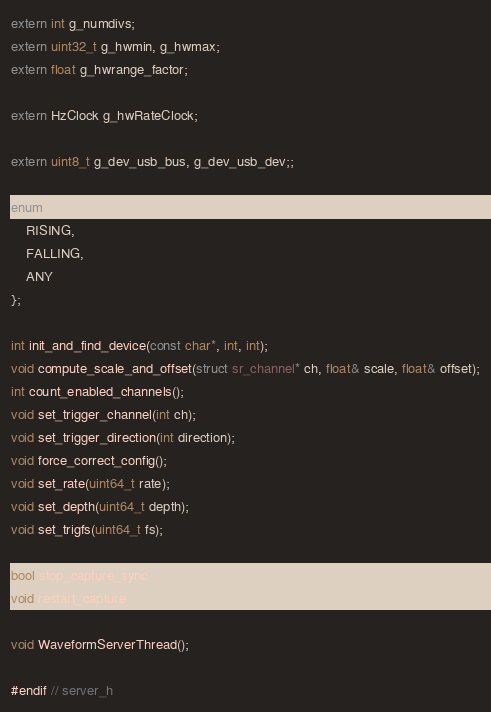<code> <loc_0><loc_0><loc_500><loc_500><_C_>extern int g_numdivs;
extern uint32_t g_hwmin, g_hwmax;
extern float g_hwrange_factor;

extern HzClock g_hwRateClock;

extern uint8_t g_dev_usb_bus, g_dev_usb_dev;;

enum trigger_direction {
	RISING,
	FALLING,
	ANY
};

int init_and_find_device(const char*, int, int);
void compute_scale_and_offset(struct sr_channel* ch, float& scale, float& offset);
int count_enabled_channels();
void set_trigger_channel(int ch);
void set_trigger_direction(int direction);
void force_correct_config();
void set_rate(uint64_t rate);
void set_depth(uint64_t depth);
void set_trigfs(uint64_t fs);

bool stop_capture_sync();
void restart_capture();

void WaveformServerThread();

#endif // server_h
</code> 